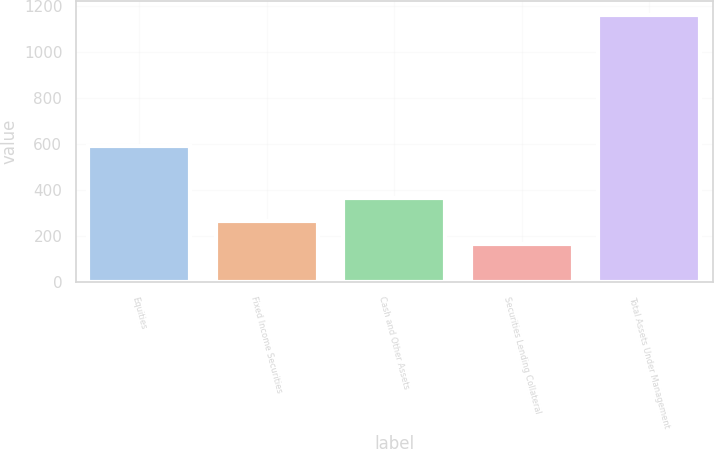<chart> <loc_0><loc_0><loc_500><loc_500><bar_chart><fcel>Equities<fcel>Fixed Income Securities<fcel>Cash and Other Assets<fcel>Securities Lending Collateral<fcel>Total Assets Under Management<nl><fcel>592.3<fcel>267.03<fcel>366.36<fcel>167.7<fcel>1161<nl></chart> 